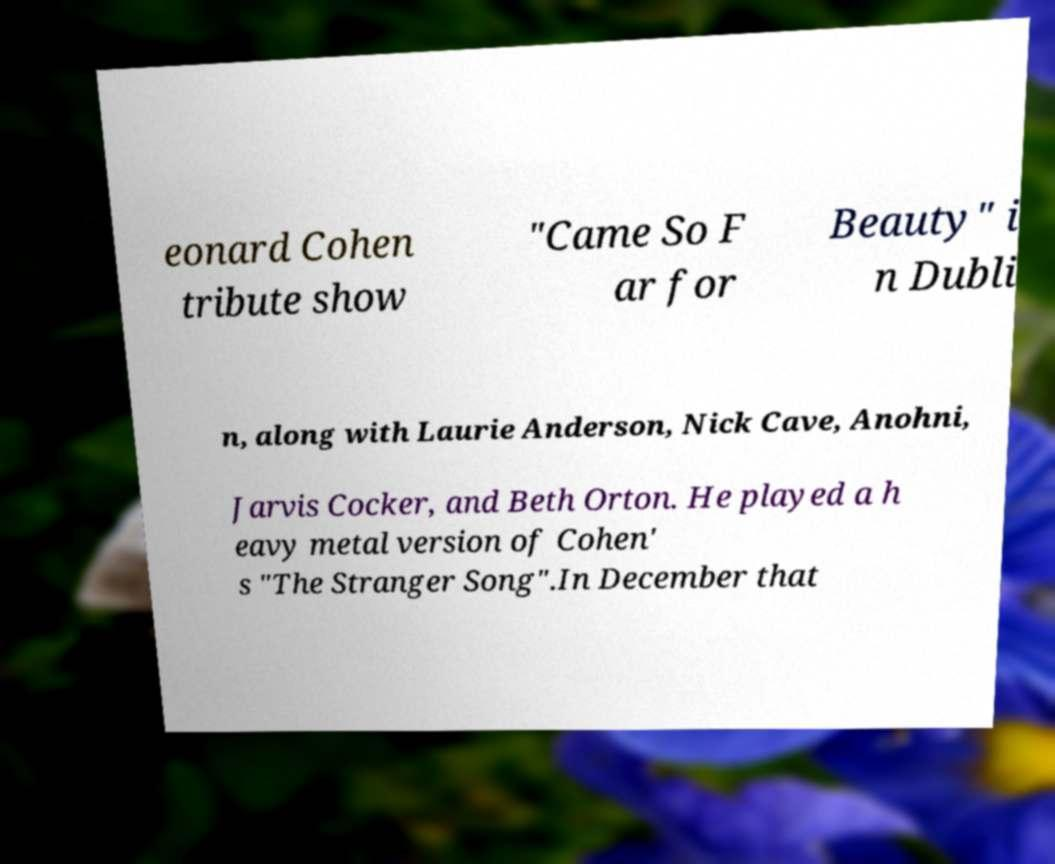Please read and relay the text visible in this image. What does it say? eonard Cohen tribute show "Came So F ar for Beauty" i n Dubli n, along with Laurie Anderson, Nick Cave, Anohni, Jarvis Cocker, and Beth Orton. He played a h eavy metal version of Cohen' s "The Stranger Song".In December that 